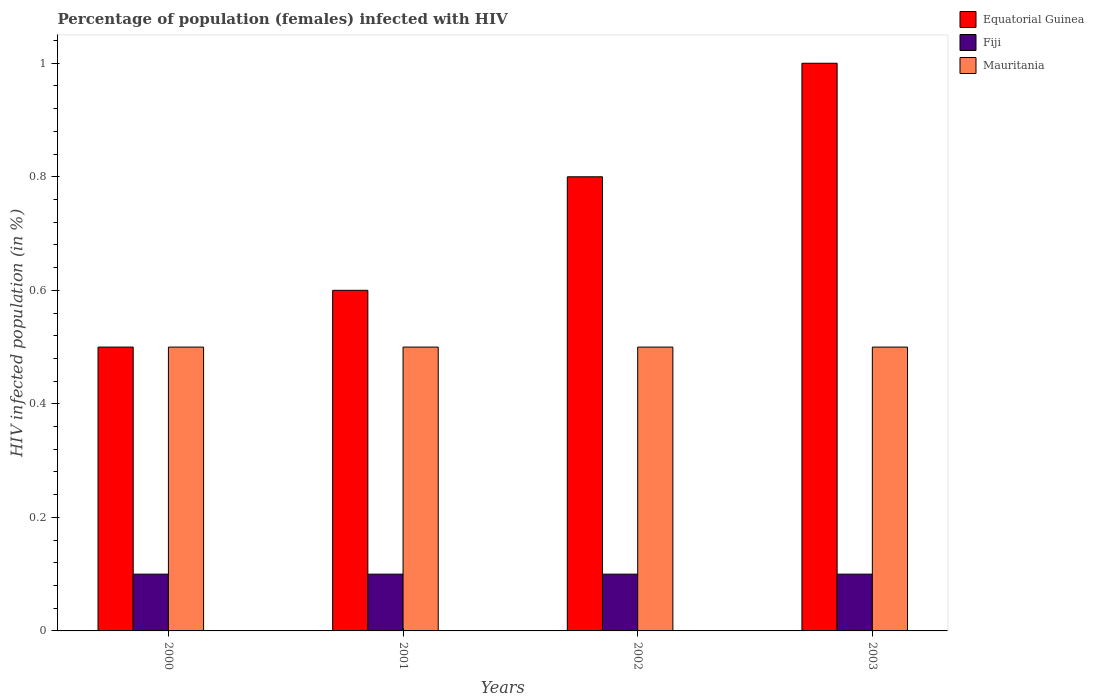How many bars are there on the 1st tick from the left?
Keep it short and to the point. 3. In which year was the percentage of HIV infected female population in Equatorial Guinea maximum?
Offer a terse response. 2003. In which year was the percentage of HIV infected female population in Fiji minimum?
Make the answer very short. 2000. What is the total percentage of HIV infected female population in Equatorial Guinea in the graph?
Keep it short and to the point. 2.9. What is the difference between the percentage of HIV infected female population in Equatorial Guinea in 2001 and that in 2003?
Make the answer very short. -0.4. What is the average percentage of HIV infected female population in Equatorial Guinea per year?
Make the answer very short. 0.73. In the year 2000, what is the difference between the percentage of HIV infected female population in Mauritania and percentage of HIV infected female population in Fiji?
Provide a succinct answer. 0.4. Is the difference between the percentage of HIV infected female population in Mauritania in 2000 and 2003 greater than the difference between the percentage of HIV infected female population in Fiji in 2000 and 2003?
Your response must be concise. No. What is the difference between the highest and the second highest percentage of HIV infected female population in Fiji?
Give a very brief answer. 0. What does the 1st bar from the left in 2002 represents?
Give a very brief answer. Equatorial Guinea. What does the 2nd bar from the right in 2000 represents?
Ensure brevity in your answer.  Fiji. Is it the case that in every year, the sum of the percentage of HIV infected female population in Mauritania and percentage of HIV infected female population in Fiji is greater than the percentage of HIV infected female population in Equatorial Guinea?
Provide a succinct answer. No. What is the difference between two consecutive major ticks on the Y-axis?
Your response must be concise. 0.2. Are the values on the major ticks of Y-axis written in scientific E-notation?
Your response must be concise. No. Does the graph contain grids?
Your answer should be compact. No. Where does the legend appear in the graph?
Give a very brief answer. Top right. How are the legend labels stacked?
Offer a very short reply. Vertical. What is the title of the graph?
Make the answer very short. Percentage of population (females) infected with HIV. Does "India" appear as one of the legend labels in the graph?
Your response must be concise. No. What is the label or title of the X-axis?
Your answer should be compact. Years. What is the label or title of the Y-axis?
Provide a succinct answer. HIV infected population (in %). What is the HIV infected population (in %) of Fiji in 2000?
Make the answer very short. 0.1. What is the HIV infected population (in %) in Mauritania in 2000?
Provide a short and direct response. 0.5. What is the HIV infected population (in %) in Equatorial Guinea in 2001?
Your answer should be compact. 0.6. What is the HIV infected population (in %) of Fiji in 2001?
Offer a terse response. 0.1. What is the HIV infected population (in %) of Fiji in 2002?
Keep it short and to the point. 0.1. What is the HIV infected population (in %) in Equatorial Guinea in 2003?
Your answer should be very brief. 1. What is the HIV infected population (in %) in Fiji in 2003?
Offer a very short reply. 0.1. What is the HIV infected population (in %) in Mauritania in 2003?
Offer a very short reply. 0.5. Across all years, what is the maximum HIV infected population (in %) of Fiji?
Ensure brevity in your answer.  0.1. Across all years, what is the maximum HIV infected population (in %) of Mauritania?
Your answer should be compact. 0.5. Across all years, what is the minimum HIV infected population (in %) in Fiji?
Offer a very short reply. 0.1. Across all years, what is the minimum HIV infected population (in %) of Mauritania?
Provide a succinct answer. 0.5. What is the total HIV infected population (in %) of Equatorial Guinea in the graph?
Give a very brief answer. 2.9. What is the total HIV infected population (in %) in Mauritania in the graph?
Your response must be concise. 2. What is the difference between the HIV infected population (in %) of Equatorial Guinea in 2000 and that in 2001?
Give a very brief answer. -0.1. What is the difference between the HIV infected population (in %) of Equatorial Guinea in 2000 and that in 2002?
Offer a very short reply. -0.3. What is the difference between the HIV infected population (in %) of Fiji in 2000 and that in 2003?
Offer a terse response. 0. What is the difference between the HIV infected population (in %) in Mauritania in 2000 and that in 2003?
Provide a succinct answer. 0. What is the difference between the HIV infected population (in %) of Fiji in 2001 and that in 2002?
Offer a terse response. 0. What is the difference between the HIV infected population (in %) of Fiji in 2001 and that in 2003?
Ensure brevity in your answer.  0. What is the difference between the HIV infected population (in %) in Equatorial Guinea in 2000 and the HIV infected population (in %) in Fiji in 2001?
Offer a very short reply. 0.4. What is the difference between the HIV infected population (in %) of Fiji in 2000 and the HIV infected population (in %) of Mauritania in 2001?
Make the answer very short. -0.4. What is the difference between the HIV infected population (in %) of Equatorial Guinea in 2000 and the HIV infected population (in %) of Fiji in 2002?
Provide a short and direct response. 0.4. What is the difference between the HIV infected population (in %) in Equatorial Guinea in 2000 and the HIV infected population (in %) in Mauritania in 2002?
Your response must be concise. 0. What is the difference between the HIV infected population (in %) of Fiji in 2000 and the HIV infected population (in %) of Mauritania in 2002?
Your response must be concise. -0.4. What is the difference between the HIV infected population (in %) in Equatorial Guinea in 2001 and the HIV infected population (in %) in Fiji in 2002?
Give a very brief answer. 0.5. What is the difference between the HIV infected population (in %) in Equatorial Guinea in 2001 and the HIV infected population (in %) in Mauritania in 2002?
Give a very brief answer. 0.1. What is the difference between the HIV infected population (in %) of Fiji in 2001 and the HIV infected population (in %) of Mauritania in 2002?
Provide a succinct answer. -0.4. What is the difference between the HIV infected population (in %) in Equatorial Guinea in 2001 and the HIV infected population (in %) in Fiji in 2003?
Keep it short and to the point. 0.5. What is the difference between the HIV infected population (in %) in Fiji in 2001 and the HIV infected population (in %) in Mauritania in 2003?
Give a very brief answer. -0.4. What is the difference between the HIV infected population (in %) in Equatorial Guinea in 2002 and the HIV infected population (in %) in Fiji in 2003?
Your answer should be very brief. 0.7. What is the average HIV infected population (in %) in Equatorial Guinea per year?
Provide a short and direct response. 0.72. What is the average HIV infected population (in %) of Mauritania per year?
Give a very brief answer. 0.5. In the year 2001, what is the difference between the HIV infected population (in %) in Equatorial Guinea and HIV infected population (in %) in Fiji?
Keep it short and to the point. 0.5. In the year 2001, what is the difference between the HIV infected population (in %) of Fiji and HIV infected population (in %) of Mauritania?
Offer a very short reply. -0.4. In the year 2002, what is the difference between the HIV infected population (in %) in Equatorial Guinea and HIV infected population (in %) in Fiji?
Provide a short and direct response. 0.7. In the year 2002, what is the difference between the HIV infected population (in %) in Fiji and HIV infected population (in %) in Mauritania?
Keep it short and to the point. -0.4. In the year 2003, what is the difference between the HIV infected population (in %) in Equatorial Guinea and HIV infected population (in %) in Fiji?
Provide a succinct answer. 0.9. In the year 2003, what is the difference between the HIV infected population (in %) of Fiji and HIV infected population (in %) of Mauritania?
Offer a terse response. -0.4. What is the ratio of the HIV infected population (in %) of Equatorial Guinea in 2000 to that in 2001?
Offer a very short reply. 0.83. What is the ratio of the HIV infected population (in %) of Equatorial Guinea in 2000 to that in 2002?
Provide a short and direct response. 0.62. What is the ratio of the HIV infected population (in %) of Fiji in 2000 to that in 2002?
Provide a succinct answer. 1. What is the ratio of the HIV infected population (in %) of Mauritania in 2000 to that in 2003?
Offer a very short reply. 1. What is the ratio of the HIV infected population (in %) in Equatorial Guinea in 2001 to that in 2003?
Your answer should be compact. 0.6. What is the ratio of the HIV infected population (in %) in Mauritania in 2001 to that in 2003?
Keep it short and to the point. 1. What is the ratio of the HIV infected population (in %) in Fiji in 2002 to that in 2003?
Give a very brief answer. 1. What is the ratio of the HIV infected population (in %) in Mauritania in 2002 to that in 2003?
Your answer should be compact. 1. What is the difference between the highest and the second highest HIV infected population (in %) in Equatorial Guinea?
Your answer should be compact. 0.2. What is the difference between the highest and the second highest HIV infected population (in %) in Fiji?
Give a very brief answer. 0. 